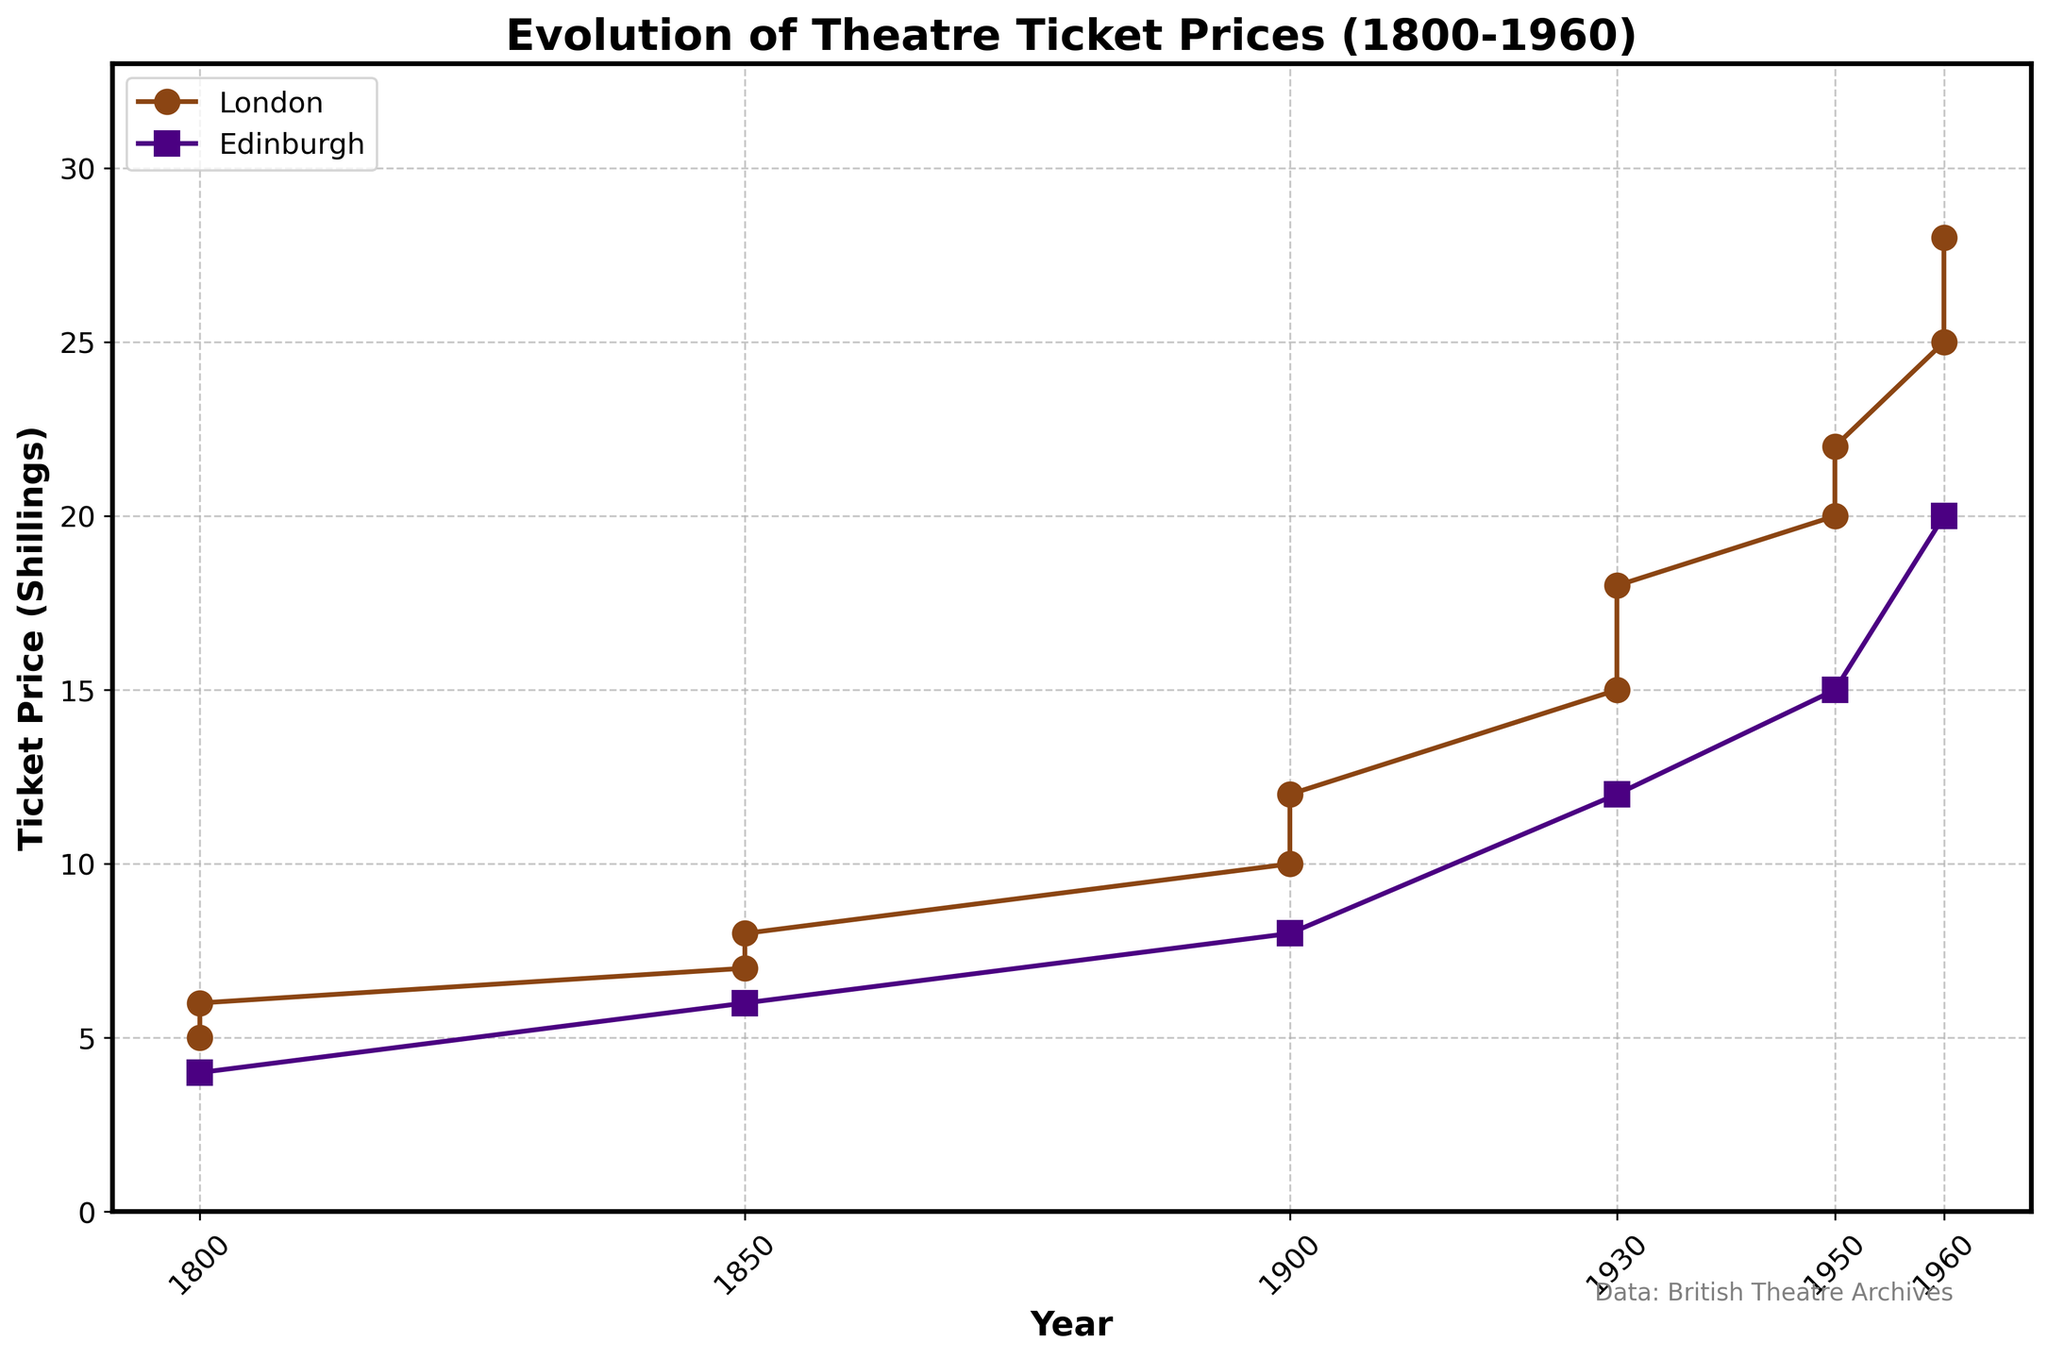What is the title of the plot? The title is prominently displayed at the top of the plot and provides the overall context.
Answer: Evolution of Theatre Ticket Prices (1800-1960) Which years are marked on the x-axis? The x-axis represents the years and is marked with intervals visible at each data point in the time range.
Answer: 1800, 1850, 1900, 1930, 1950, 1960 What is the highest ticket price recorded, and in which city and year was it? Identify the peak value on the y-axis and correlate it with the year and city lines on the plot.
Answer: 28 shillings in London, 1960 What is the difference in ticket price between London and Edinburgh in 1900? Look at the y-axis values for both cities in 1900 and subtract the smaller price from the larger one.
Answer: 4 shillings Which city shows the most significant increase in ticket prices from 1800 to 1960? Compare the beginning and end values of the lines representing each city to see which city has the greatest difference.
Answer: London How did the ticket prices in Edinburgh change from 1900 to 1960? Observe the line for Edinburgh at these specific years and note the ticket prices to calculate the difference.
Answer: Increased from 8 to 20 shillings Compare the ticket prices in London and Edinburgh in 1930. Which was higher? Identify the points on the lines representing London and Edinburgh in 1930 and compare their y-axis values.
Answer: London On average, how much did the ticket prices in London increase per half-century from 1800 to 1960? Calculate the total increase in London ticket prices across the specified years and divide by the number of half-century periods (160 shillings / 3).
Answer: Approximately 5.33 shillings What is the average ticket price for the Covent Garden Theatre in London over the years shown? Add the ticket prices for Covent Garden Theatre for all years and divide by the number of data points (6 + 8 + 12 + 18 + 22 + 28 = 94 shillings / 6).
Answer: 15.67 shillings In which city was the smallest ticket price found in 1850, and what was it? Look at the ticket prices for each city in 1850 and identify the smallest value.
Answer: Edinburgh, 6 shillings 